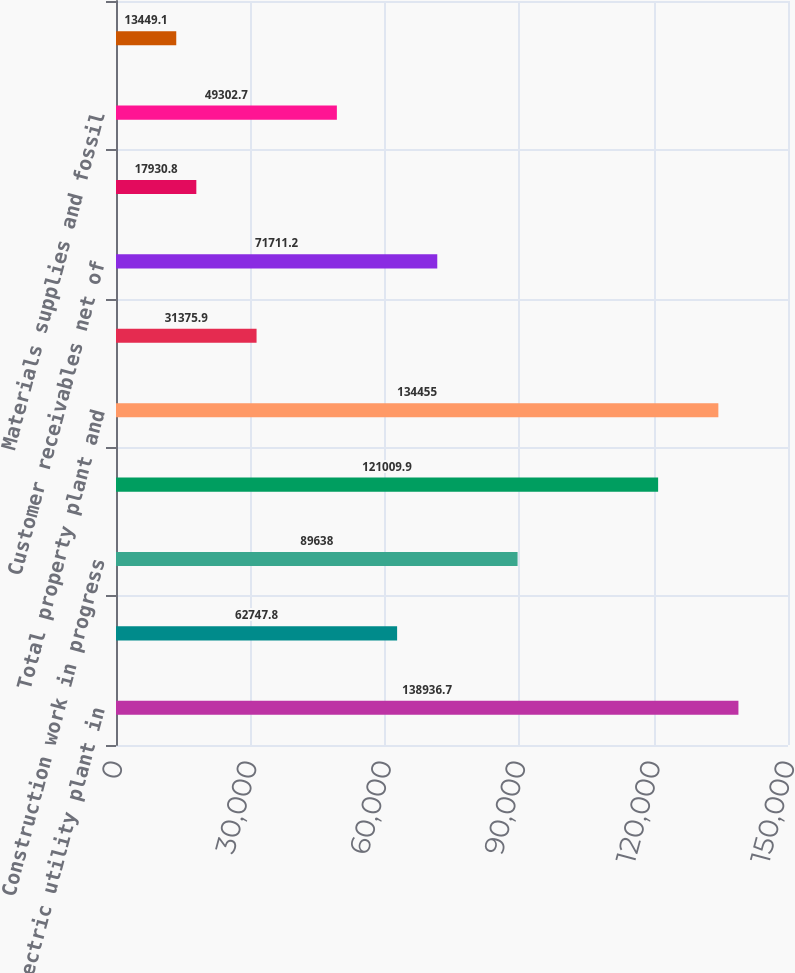Convert chart to OTSL. <chart><loc_0><loc_0><loc_500><loc_500><bar_chart><fcel>Electric utility plant in<fcel>Nuclear fuel<fcel>Construction work in progress<fcel>Less accumulated depreciation<fcel>Total property plant and<fcel>Cash and cash equivalents<fcel>Customer receivables net of<fcel>Other receivables net of<fcel>Materials supplies and fossil<fcel>Deferred clause and franchise<nl><fcel>138937<fcel>62747.8<fcel>89638<fcel>121010<fcel>134455<fcel>31375.9<fcel>71711.2<fcel>17930.8<fcel>49302.7<fcel>13449.1<nl></chart> 